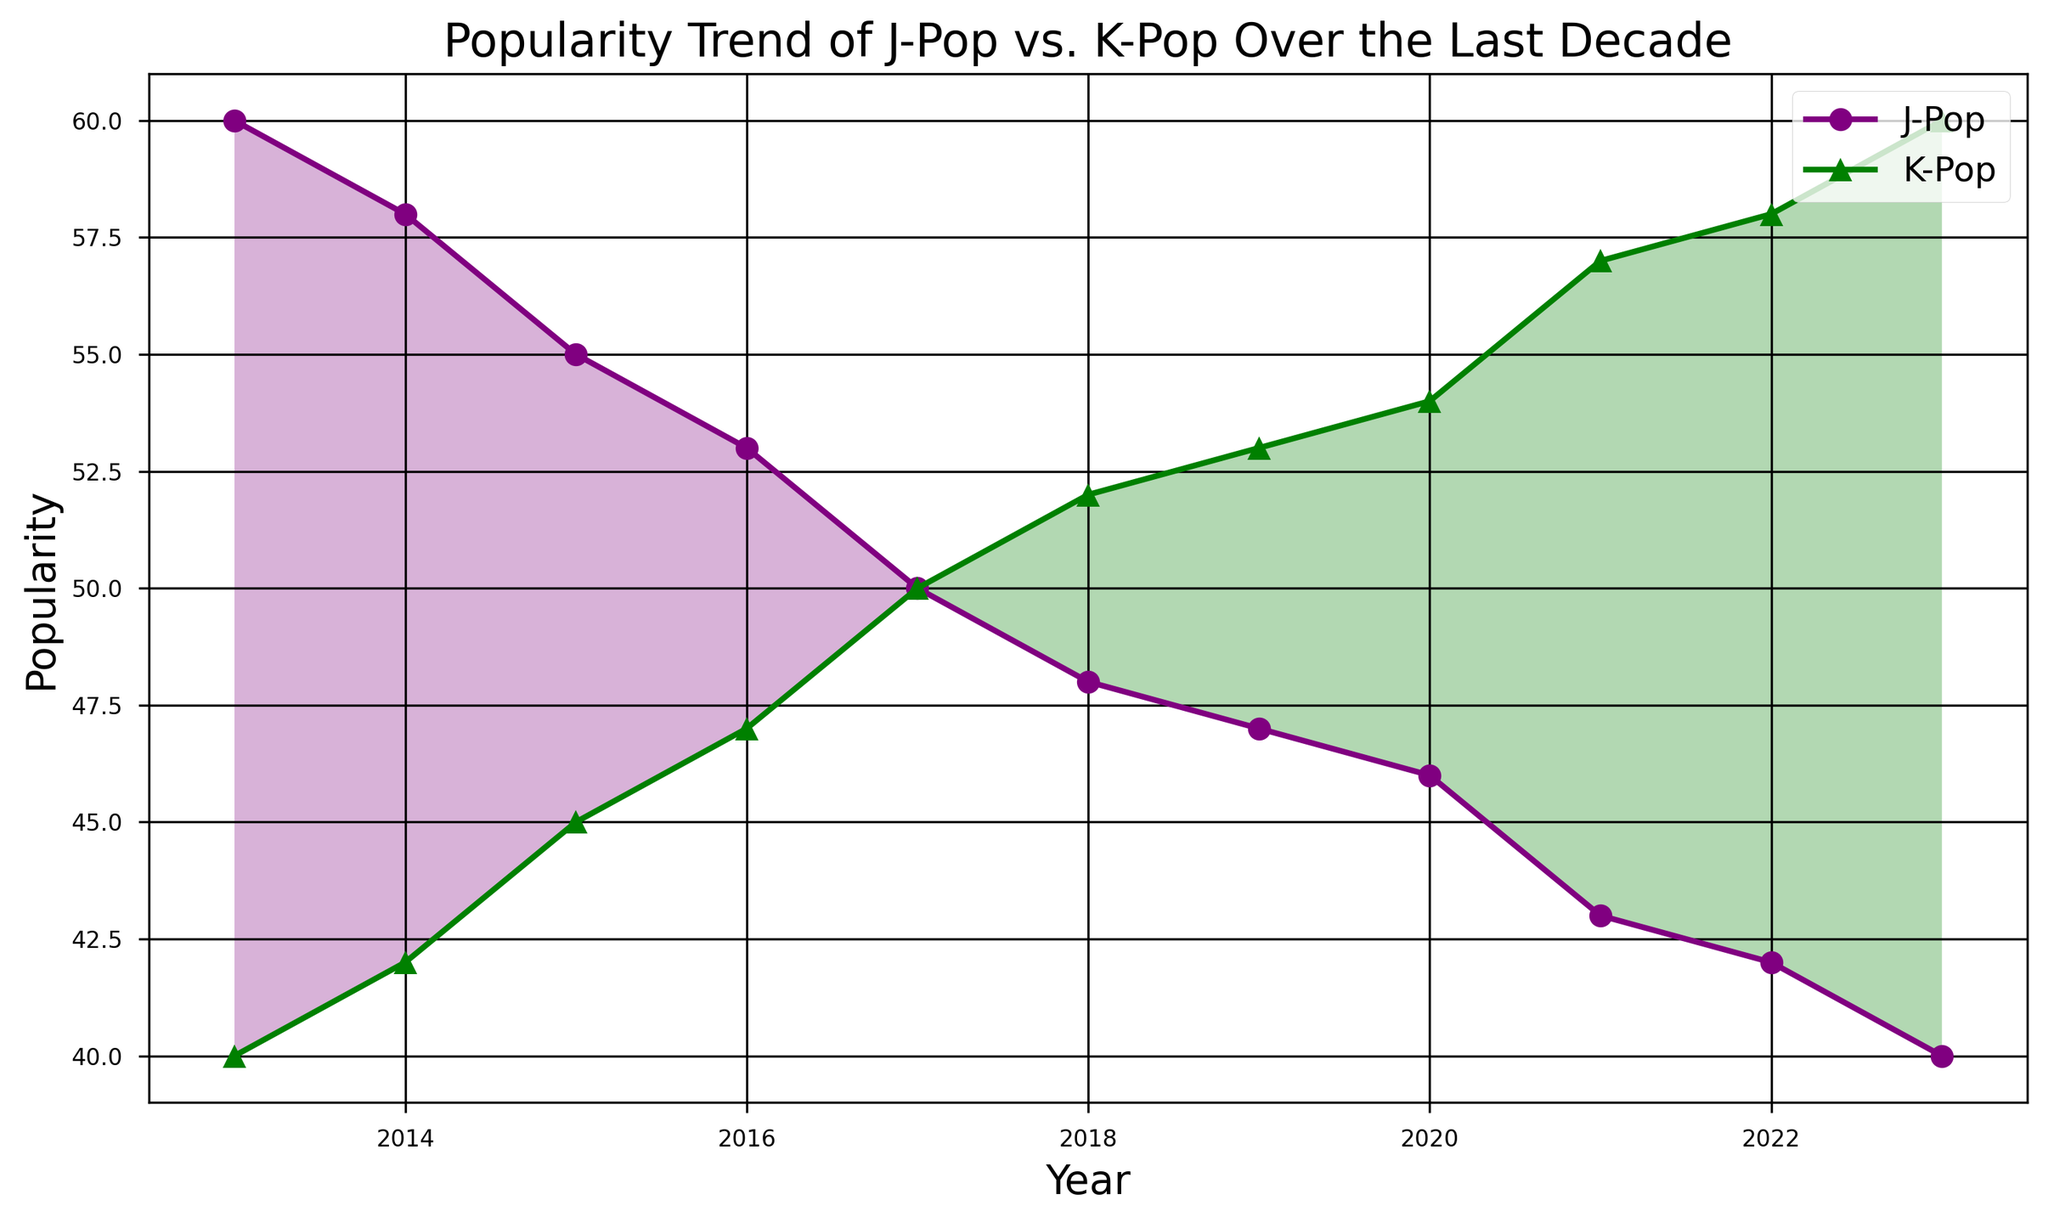What's the general trend for J-Pop popularity from 2013 to 2023? To determine the general trend, look at the line representing J-Pop popularity. From 2013 (60) to 2023 (40), the line shows a declining trend.
Answer: Declining Which year did K-Pop and J-Pop have equal popularity? Find the intersection point of the two lines. Both J-Pop and K-Pop hit 50 in the year 2017.
Answer: 2017 In which year did K-Pop surpass J-Pop in popularity? Look at the point where the green line (K-Pop) starts being above the purple line (J-Pop). This happens after 2017.
Answer: 2018 By how much did K-Pop popularity increase from 2013 to 2023? Calculate the difference between K-Pop popularity in 2023 (60) and in 2013 (40). The increase is 60 - 40 = 20.
Answer: 20 In which years did the popularity difference between J-Pop and K-Pop exceed 10 units? Find the years when the absolute difference between J-Pop and K-Pop popularity is more than 10. This occurs in 2022 (42 for J-Pop, 58 for K-Pop) and 2023 (40 for J-Pop, 60 for K-Pop).
Answer: 2022, 2023 What's the average popularity of J-Pop over the decade? Sum all the J-Pop popularity values from 2013 to 2023 (60 + 58 + 55 + 53 + 50 + 48 + 47 + 46 + 43 + 42 + 40 = 492) and divide by 11 years: 492 / 11 = 44.73.
Answer: 44.73 Describe the visual difference in the filled areas between the trends of J-Pop and K-Pop. The areas filled with purple indicate when J-Pop is more popular than K-Pop, while the areas filled with green show when K-Pop is more popular than J-Pop. The green area grows larger from 2018 onwards, indicating K-Pop's increasing dominance.
Answer: More green after 2018 What was the decline in J-Pop popularity from 2017 to 2023? Find the difference in J-Pop popularity between 2017 (50) and 2023 (40). The decline is 50 - 40 = 10.
Answer: 10 Is there any year when the popularity difference between J-Pop and K-Pop is zero? Check if there is any year where the two lines intersect, indicating equal popularity. They intersect in 2017.
Answer: Yes, 2017 How did J-Pop's popularity change between 2015 and 2018? Look at J-Pop popularity in 2015 (55) and in 2018 (48). The change is 55 - 48 = 7 (decline).
Answer: 7 unité 